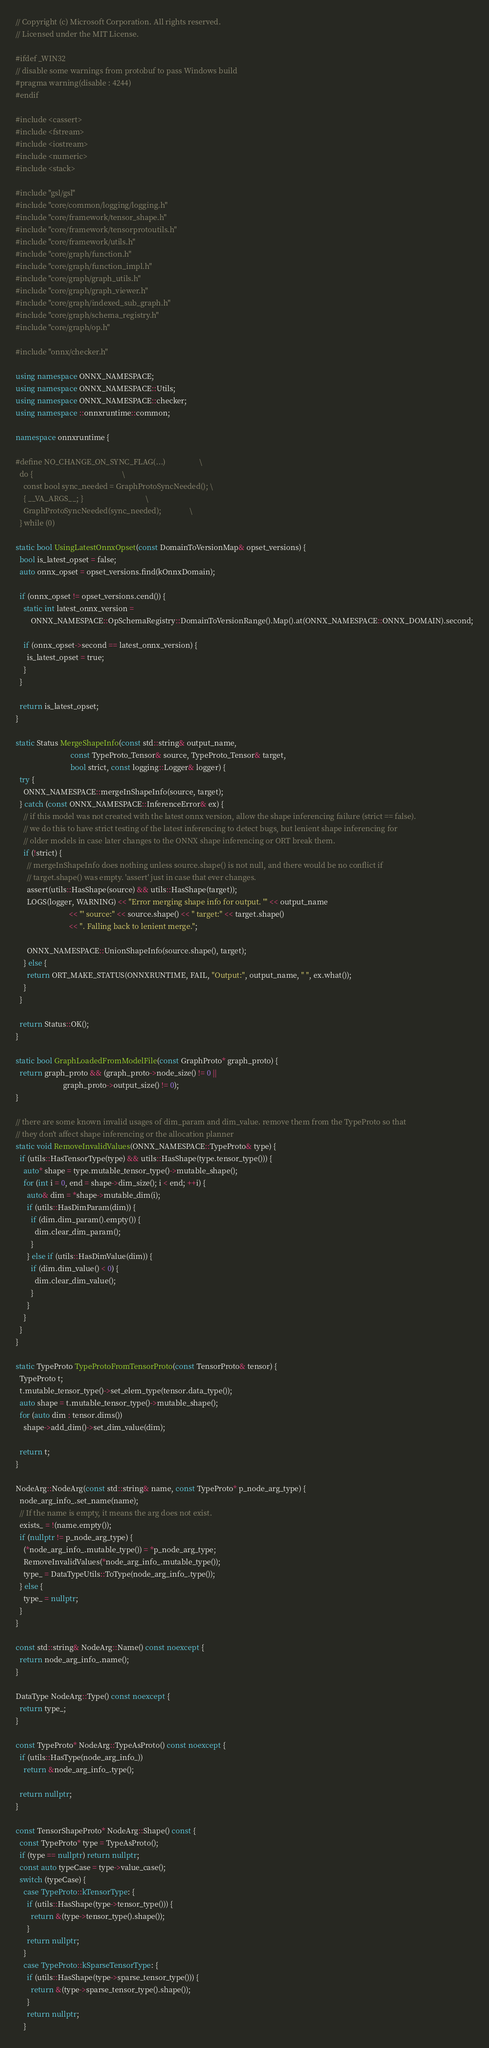Convert code to text. <code><loc_0><loc_0><loc_500><loc_500><_C++_>// Copyright (c) Microsoft Corporation. All rights reserved.
// Licensed under the MIT License.

#ifdef _WIN32
// disable some warnings from protobuf to pass Windows build
#pragma warning(disable : 4244)
#endif

#include <cassert>
#include <fstream>
#include <iostream>
#include <numeric>
#include <stack>

#include "gsl/gsl"
#include "core/common/logging/logging.h"
#include "core/framework/tensor_shape.h"
#include "core/framework/tensorprotoutils.h"
#include "core/framework/utils.h"
#include "core/graph/function.h"
#include "core/graph/function_impl.h"
#include "core/graph/graph_utils.h"
#include "core/graph/graph_viewer.h"
#include "core/graph/indexed_sub_graph.h"
#include "core/graph/schema_registry.h"
#include "core/graph/op.h"

#include "onnx/checker.h"

using namespace ONNX_NAMESPACE;
using namespace ONNX_NAMESPACE::Utils;
using namespace ONNX_NAMESPACE::checker;
using namespace ::onnxruntime::common;

namespace onnxruntime {

#define NO_CHANGE_ON_SYNC_FLAG(...)                  \
  do {                                               \
    const bool sync_needed = GraphProtoSyncNeeded(); \
    { __VA_ARGS__; }                                 \
    GraphProtoSyncNeeded(sync_needed);               \
  } while (0)

static bool UsingLatestOnnxOpset(const DomainToVersionMap& opset_versions) {
  bool is_latest_opset = false;
  auto onnx_opset = opset_versions.find(kOnnxDomain);

  if (onnx_opset != opset_versions.cend()) {
    static int latest_onnx_version =
        ONNX_NAMESPACE::OpSchemaRegistry::DomainToVersionRange().Map().at(ONNX_NAMESPACE::ONNX_DOMAIN).second;

    if (onnx_opset->second == latest_onnx_version) {
      is_latest_opset = true;
    }
  }

  return is_latest_opset;
}

static Status MergeShapeInfo(const std::string& output_name,
                             const TypeProto_Tensor& source, TypeProto_Tensor& target,
                             bool strict, const logging::Logger& logger) {
  try {
    ONNX_NAMESPACE::mergeInShapeInfo(source, target);
  } catch (const ONNX_NAMESPACE::InferenceError& ex) {
    // if this model was not created with the latest onnx version, allow the shape inferencing failure (strict == false).
    // we do this to have strict testing of the latest inferencing to detect bugs, but lenient shape inferencing for
    // older models in case later changes to the ONNX shape inferencing or ORT break them.
    if (!strict) {
      // mergeInShapeInfo does nothing unless source.shape() is not null, and there would be no conflict if
      // target.shape() was empty. 'assert' just in case that ever changes.
      assert(utils::HasShape(source) && utils::HasShape(target));
      LOGS(logger, WARNING) << "Error merging shape info for output. '" << output_name
                            << "' source:" << source.shape() << " target:" << target.shape()
                            << ". Falling back to lenient merge.";

      ONNX_NAMESPACE::UnionShapeInfo(source.shape(), target);
    } else {
      return ORT_MAKE_STATUS(ONNXRUNTIME, FAIL, "Output:", output_name, " ", ex.what());
    }
  }

  return Status::OK();
}

static bool GraphLoadedFromModelFile(const GraphProto* graph_proto) {
  return graph_proto && (graph_proto->node_size() != 0 ||
                         graph_proto->output_size() != 0);
}

// there are some known invalid usages of dim_param and dim_value. remove them from the TypeProto so that
// they don't affect shape inferencing or the allocation planner
static void RemoveInvalidValues(ONNX_NAMESPACE::TypeProto& type) {
  if (utils::HasTensorType(type) && utils::HasShape(type.tensor_type())) {
    auto* shape = type.mutable_tensor_type()->mutable_shape();
    for (int i = 0, end = shape->dim_size(); i < end; ++i) {
      auto& dim = *shape->mutable_dim(i);
      if (utils::HasDimParam(dim)) {
        if (dim.dim_param().empty()) {
          dim.clear_dim_param();
        }
      } else if (utils::HasDimValue(dim)) {
        if (dim.dim_value() < 0) {
          dim.clear_dim_value();
        }
      }
    }
  }
}

static TypeProto TypeProtoFromTensorProto(const TensorProto& tensor) {
  TypeProto t;
  t.mutable_tensor_type()->set_elem_type(tensor.data_type());
  auto shape = t.mutable_tensor_type()->mutable_shape();
  for (auto dim : tensor.dims())
    shape->add_dim()->set_dim_value(dim);

  return t;
}

NodeArg::NodeArg(const std::string& name, const TypeProto* p_node_arg_type) {
  node_arg_info_.set_name(name);
  // If the name is empty, it means the arg does not exist.
  exists_ = !(name.empty());
  if (nullptr != p_node_arg_type) {
    (*node_arg_info_.mutable_type()) = *p_node_arg_type;
    RemoveInvalidValues(*node_arg_info_.mutable_type());
    type_ = DataTypeUtils::ToType(node_arg_info_.type());
  } else {
    type_ = nullptr;
  }
}

const std::string& NodeArg::Name() const noexcept {
  return node_arg_info_.name();
}

DataType NodeArg::Type() const noexcept {
  return type_;
}

const TypeProto* NodeArg::TypeAsProto() const noexcept {
  if (utils::HasType(node_arg_info_))
    return &node_arg_info_.type();

  return nullptr;
}

const TensorShapeProto* NodeArg::Shape() const {
  const TypeProto* type = TypeAsProto();
  if (type == nullptr) return nullptr;
  const auto typeCase = type->value_case();
  switch (typeCase) {
    case TypeProto::kTensorType: {
      if (utils::HasShape(type->tensor_type())) {
        return &(type->tensor_type().shape());
      }
      return nullptr;
    }
    case TypeProto::kSparseTensorType: {
      if (utils::HasShape(type->sparse_tensor_type())) {
        return &(type->sparse_tensor_type().shape());
      }
      return nullptr;
    }</code> 